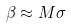Convert formula to latex. <formula><loc_0><loc_0><loc_500><loc_500>\beta \approx M \sigma</formula> 